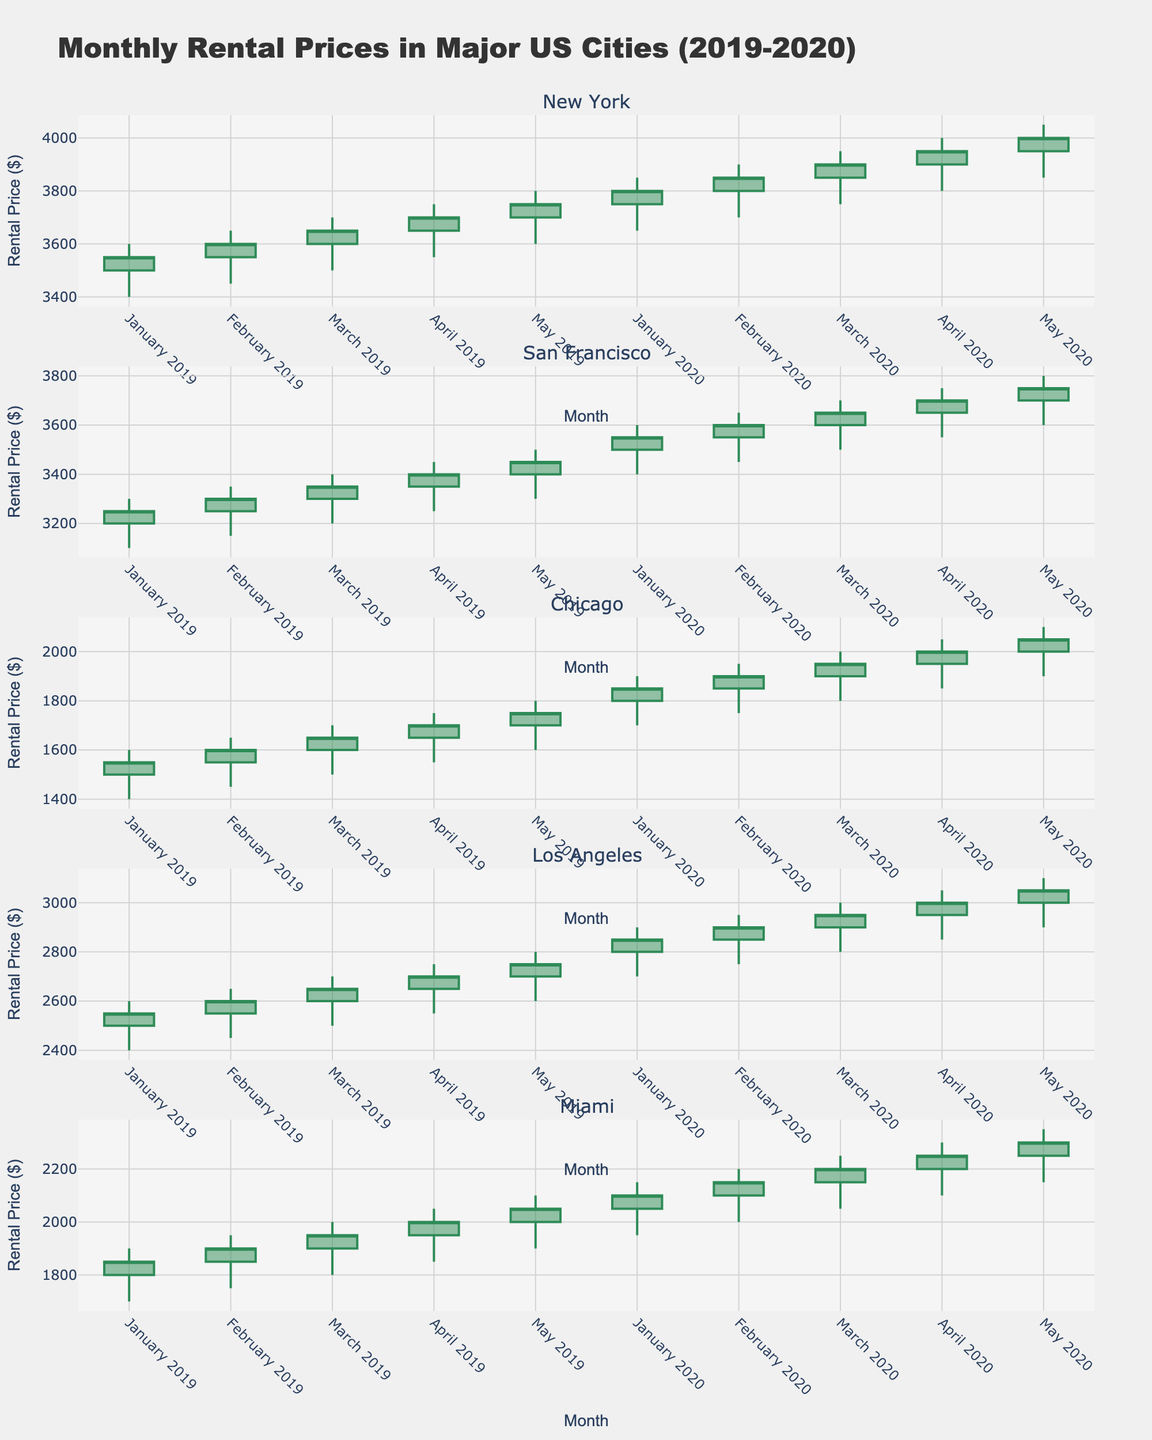What is the title of the figure? The title is found at the top of the plot and provides an overview of what the figure is about.
Answer: Monthly Rental Prices in Major US Cities (2019-2020) How many cities are represented in the figure? To find the number of cities, look at the number of subplot titles or rows in the figure.
Answer: 5 Which city had the highest rental price in January 2019? Identify the highest price point in the January 2019 candlestick for each city and compare them. New York's highest is $3600, which is the highest compared to the others.
Answer: New York How did the rental prices in Los Angeles change from January 2019 to May 2019? Observe the candlesticks for Los Angeles from January 2019 to May 2019. The open and close values indicate an increase over these months.
Answer: Increased What is the average closing price for Chicago in the year 2020? Calculate the average by summing all closing prices for Chicago in 2020 and dividing by the number of months. (1850 + 1900 + 1950 + 2000 + 2050) / 5 = 1950
Answer: 1950 Did rental prices in Miami increase or decrease from February to March in 2020? Compare the closing price of February ($2150) to March ($2200). Since $2200 > $2150, prices increased.
Answer: Increased Which city showed a consistent increase in rental prices each month in 2019? Check each city’s monthly candlesticks for 2019 to see if the closing price consistently increased each month. San Francisco shows a consistent increase.
Answer: San Francisco What is the highest rental price recorded in the two-year period and in which city? Look for the highest point on the candlesticks across the entire figure. New York in May 2020 is $4050, which appears to be the highest.
Answer: New York Compare the rental price trends in New York and San Francisco in 2020. Which city had more fluctuations? Analyze the length and size of the candlesticks’ wicks and bodies for both cities. Larger wicks and body variations in New York indicate more fluctuations compared to San Francisco.
Answer: New York What's the total increase in closing prices for Miami from January 2019 to May 2020? Sum the difference from each closing price month-on-month for Miami from Jan 2019 ($1850) ending at May 2020 ($2300). The total increase is $2300 - $1850 = $450.
Answer: $450 